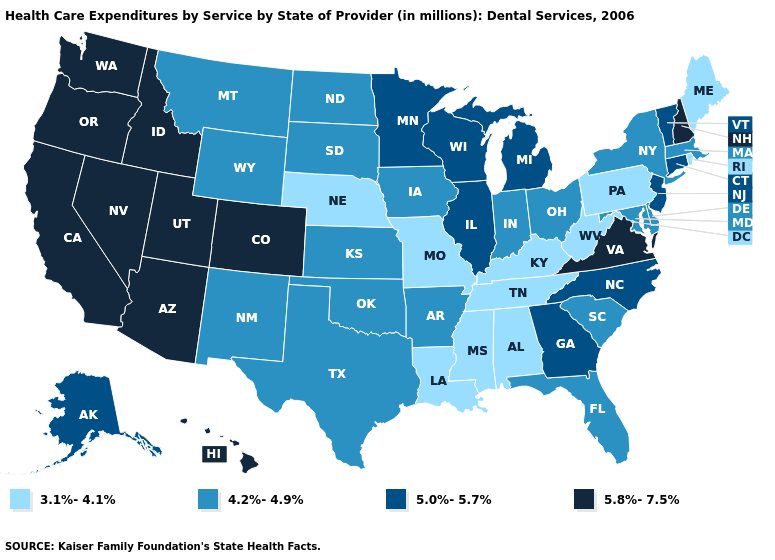Does Virginia have the highest value in the USA?
Quick response, please. Yes. What is the value of Utah?
Give a very brief answer. 5.8%-7.5%. Does Rhode Island have the lowest value in the USA?
Short answer required. Yes. Does Washington have the same value as Nevada?
Short answer required. Yes. What is the lowest value in states that border North Dakota?
Answer briefly. 4.2%-4.9%. Does Wisconsin have a lower value than Delaware?
Write a very short answer. No. Name the states that have a value in the range 3.1%-4.1%?
Write a very short answer. Alabama, Kentucky, Louisiana, Maine, Mississippi, Missouri, Nebraska, Pennsylvania, Rhode Island, Tennessee, West Virginia. Does Oregon have the highest value in the USA?
Be succinct. Yes. Does Washington have a higher value than Utah?
Keep it brief. No. Name the states that have a value in the range 3.1%-4.1%?
Keep it brief. Alabama, Kentucky, Louisiana, Maine, Mississippi, Missouri, Nebraska, Pennsylvania, Rhode Island, Tennessee, West Virginia. Does Oklahoma have the lowest value in the USA?
Write a very short answer. No. Does the map have missing data?
Be succinct. No. What is the value of Iowa?
Concise answer only. 4.2%-4.9%. Name the states that have a value in the range 5.0%-5.7%?
Concise answer only. Alaska, Connecticut, Georgia, Illinois, Michigan, Minnesota, New Jersey, North Carolina, Vermont, Wisconsin. 